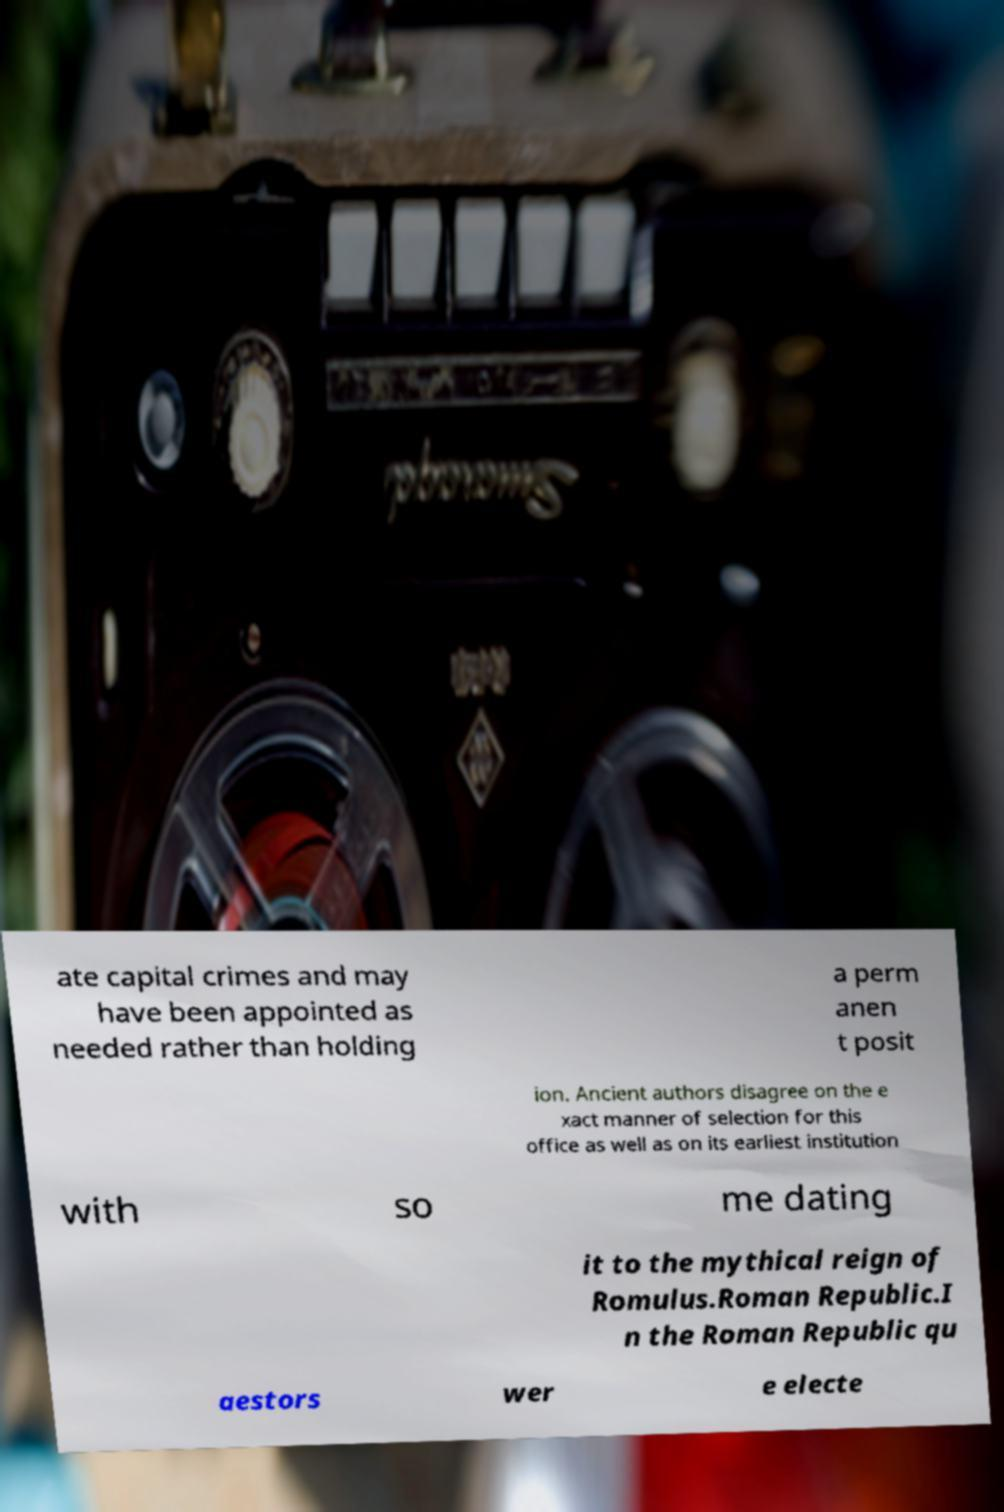Please identify and transcribe the text found in this image. ate capital crimes and may have been appointed as needed rather than holding a perm anen t posit ion. Ancient authors disagree on the e xact manner of selection for this office as well as on its earliest institution with so me dating it to the mythical reign of Romulus.Roman Republic.I n the Roman Republic qu aestors wer e electe 